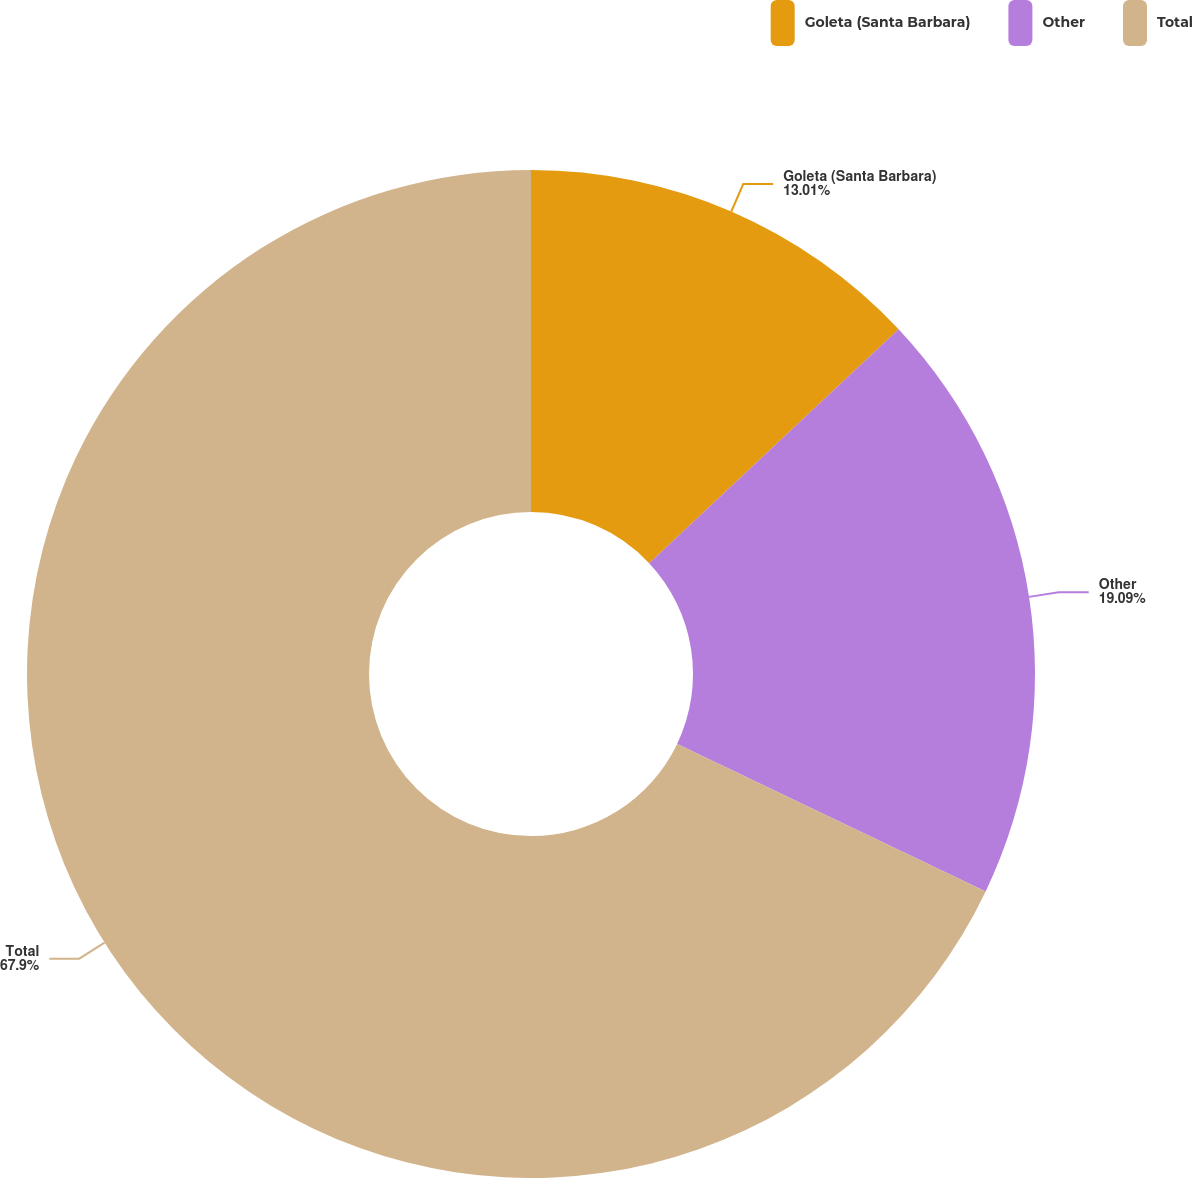Convert chart to OTSL. <chart><loc_0><loc_0><loc_500><loc_500><pie_chart><fcel>Goleta (Santa Barbara)<fcel>Other<fcel>Total<nl><fcel>13.01%<fcel>19.09%<fcel>67.9%<nl></chart> 